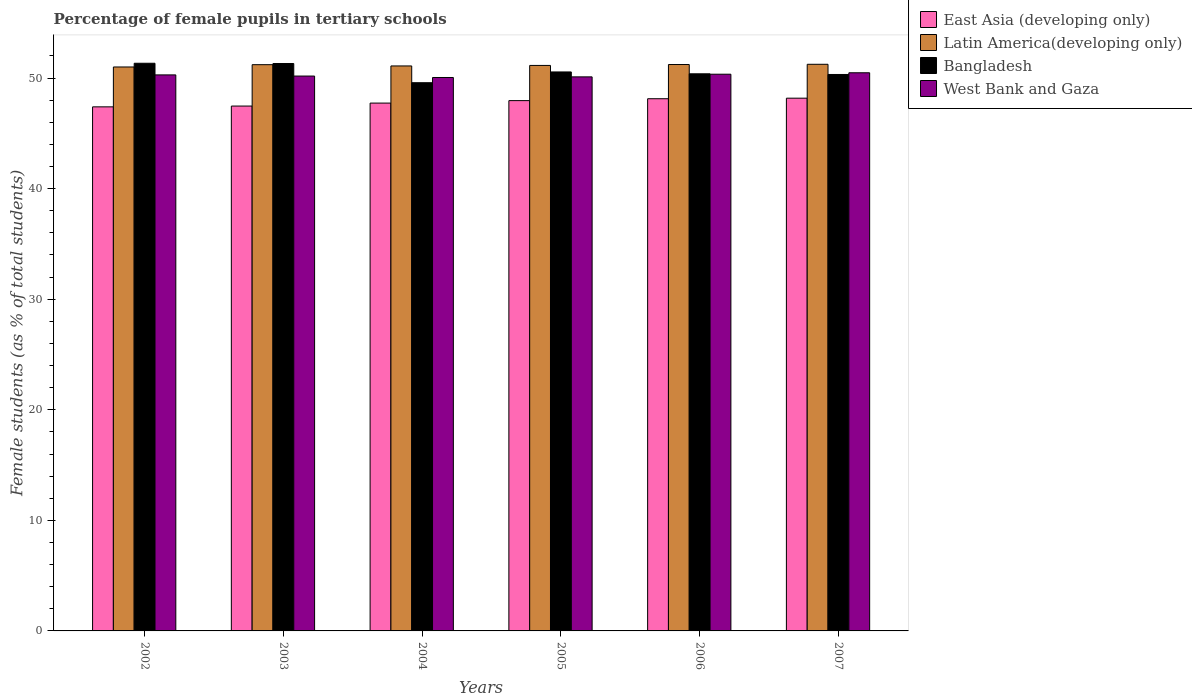How many groups of bars are there?
Offer a terse response. 6. Are the number of bars on each tick of the X-axis equal?
Provide a succinct answer. Yes. How many bars are there on the 3rd tick from the left?
Your answer should be very brief. 4. How many bars are there on the 4th tick from the right?
Keep it short and to the point. 4. What is the label of the 5th group of bars from the left?
Provide a succinct answer. 2006. What is the percentage of female pupils in tertiary schools in West Bank and Gaza in 2006?
Give a very brief answer. 50.35. Across all years, what is the maximum percentage of female pupils in tertiary schools in East Asia (developing only)?
Ensure brevity in your answer.  48.18. Across all years, what is the minimum percentage of female pupils in tertiary schools in East Asia (developing only)?
Provide a succinct answer. 47.4. In which year was the percentage of female pupils in tertiary schools in Latin America(developing only) maximum?
Ensure brevity in your answer.  2007. In which year was the percentage of female pupils in tertiary schools in East Asia (developing only) minimum?
Give a very brief answer. 2002. What is the total percentage of female pupils in tertiary schools in Bangladesh in the graph?
Offer a very short reply. 303.49. What is the difference between the percentage of female pupils in tertiary schools in Bangladesh in 2002 and that in 2007?
Your answer should be very brief. 1.01. What is the difference between the percentage of female pupils in tertiary schools in Bangladesh in 2003 and the percentage of female pupils in tertiary schools in Latin America(developing only) in 2005?
Make the answer very short. 0.17. What is the average percentage of female pupils in tertiary schools in East Asia (developing only) per year?
Offer a terse response. 47.81. In the year 2006, what is the difference between the percentage of female pupils in tertiary schools in Bangladesh and percentage of female pupils in tertiary schools in West Bank and Gaza?
Provide a short and direct response. 0.04. In how many years, is the percentage of female pupils in tertiary schools in Bangladesh greater than 12 %?
Offer a very short reply. 6. What is the ratio of the percentage of female pupils in tertiary schools in Latin America(developing only) in 2006 to that in 2007?
Ensure brevity in your answer.  1. Is the difference between the percentage of female pupils in tertiary schools in Bangladesh in 2003 and 2005 greater than the difference between the percentage of female pupils in tertiary schools in West Bank and Gaza in 2003 and 2005?
Provide a succinct answer. Yes. What is the difference between the highest and the second highest percentage of female pupils in tertiary schools in West Bank and Gaza?
Your response must be concise. 0.13. What is the difference between the highest and the lowest percentage of female pupils in tertiary schools in Bangladesh?
Your response must be concise. 1.76. In how many years, is the percentage of female pupils in tertiary schools in East Asia (developing only) greater than the average percentage of female pupils in tertiary schools in East Asia (developing only) taken over all years?
Keep it short and to the point. 3. Is the sum of the percentage of female pupils in tertiary schools in Latin America(developing only) in 2005 and 2007 greater than the maximum percentage of female pupils in tertiary schools in East Asia (developing only) across all years?
Offer a very short reply. Yes. Is it the case that in every year, the sum of the percentage of female pupils in tertiary schools in Bangladesh and percentage of female pupils in tertiary schools in East Asia (developing only) is greater than the sum of percentage of female pupils in tertiary schools in Latin America(developing only) and percentage of female pupils in tertiary schools in West Bank and Gaza?
Make the answer very short. No. What does the 1st bar from the left in 2006 represents?
Keep it short and to the point. East Asia (developing only). What does the 1st bar from the right in 2002 represents?
Offer a very short reply. West Bank and Gaza. How many years are there in the graph?
Your answer should be compact. 6. Are the values on the major ticks of Y-axis written in scientific E-notation?
Your answer should be compact. No. Does the graph contain any zero values?
Your response must be concise. No. What is the title of the graph?
Provide a short and direct response. Percentage of female pupils in tertiary schools. Does "Kyrgyz Republic" appear as one of the legend labels in the graph?
Your answer should be very brief. No. What is the label or title of the Y-axis?
Your answer should be compact. Female students (as % of total students). What is the Female students (as % of total students) in East Asia (developing only) in 2002?
Your response must be concise. 47.4. What is the Female students (as % of total students) in Latin America(developing only) in 2002?
Provide a succinct answer. 51. What is the Female students (as % of total students) of Bangladesh in 2002?
Ensure brevity in your answer.  51.34. What is the Female students (as % of total students) of West Bank and Gaza in 2002?
Offer a terse response. 50.29. What is the Female students (as % of total students) of East Asia (developing only) in 2003?
Your answer should be very brief. 47.47. What is the Female students (as % of total students) of Latin America(developing only) in 2003?
Provide a succinct answer. 51.21. What is the Female students (as % of total students) in Bangladesh in 2003?
Give a very brief answer. 51.31. What is the Female students (as % of total students) of West Bank and Gaza in 2003?
Your answer should be very brief. 50.18. What is the Female students (as % of total students) of East Asia (developing only) in 2004?
Provide a succinct answer. 47.74. What is the Female students (as % of total students) in Latin America(developing only) in 2004?
Offer a very short reply. 51.1. What is the Female students (as % of total students) of Bangladesh in 2004?
Your answer should be compact. 49.58. What is the Female students (as % of total students) in West Bank and Gaza in 2004?
Your response must be concise. 50.05. What is the Female students (as % of total students) in East Asia (developing only) in 2005?
Give a very brief answer. 47.96. What is the Female students (as % of total students) of Latin America(developing only) in 2005?
Offer a very short reply. 51.14. What is the Female students (as % of total students) in Bangladesh in 2005?
Ensure brevity in your answer.  50.55. What is the Female students (as % of total students) in West Bank and Gaza in 2005?
Your answer should be compact. 50.11. What is the Female students (as % of total students) in East Asia (developing only) in 2006?
Keep it short and to the point. 48.13. What is the Female students (as % of total students) of Latin America(developing only) in 2006?
Offer a terse response. 51.22. What is the Female students (as % of total students) in Bangladesh in 2006?
Keep it short and to the point. 50.38. What is the Female students (as % of total students) in West Bank and Gaza in 2006?
Provide a succinct answer. 50.35. What is the Female students (as % of total students) in East Asia (developing only) in 2007?
Your answer should be very brief. 48.18. What is the Female students (as % of total students) in Latin America(developing only) in 2007?
Ensure brevity in your answer.  51.24. What is the Female students (as % of total students) in Bangladesh in 2007?
Provide a short and direct response. 50.32. What is the Female students (as % of total students) in West Bank and Gaza in 2007?
Give a very brief answer. 50.48. Across all years, what is the maximum Female students (as % of total students) in East Asia (developing only)?
Your response must be concise. 48.18. Across all years, what is the maximum Female students (as % of total students) of Latin America(developing only)?
Provide a short and direct response. 51.24. Across all years, what is the maximum Female students (as % of total students) in Bangladesh?
Provide a succinct answer. 51.34. Across all years, what is the maximum Female students (as % of total students) of West Bank and Gaza?
Provide a short and direct response. 50.48. Across all years, what is the minimum Female students (as % of total students) in East Asia (developing only)?
Your answer should be very brief. 47.4. Across all years, what is the minimum Female students (as % of total students) of Latin America(developing only)?
Make the answer very short. 51. Across all years, what is the minimum Female students (as % of total students) of Bangladesh?
Keep it short and to the point. 49.58. Across all years, what is the minimum Female students (as % of total students) in West Bank and Gaza?
Give a very brief answer. 50.05. What is the total Female students (as % of total students) in East Asia (developing only) in the graph?
Ensure brevity in your answer.  286.87. What is the total Female students (as % of total students) of Latin America(developing only) in the graph?
Give a very brief answer. 306.92. What is the total Female students (as % of total students) in Bangladesh in the graph?
Offer a terse response. 303.49. What is the total Female students (as % of total students) in West Bank and Gaza in the graph?
Your answer should be very brief. 301.45. What is the difference between the Female students (as % of total students) of East Asia (developing only) in 2002 and that in 2003?
Provide a short and direct response. -0.07. What is the difference between the Female students (as % of total students) in Latin America(developing only) in 2002 and that in 2003?
Provide a short and direct response. -0.21. What is the difference between the Female students (as % of total students) in Bangladesh in 2002 and that in 2003?
Keep it short and to the point. 0.02. What is the difference between the Female students (as % of total students) of West Bank and Gaza in 2002 and that in 2003?
Your answer should be very brief. 0.1. What is the difference between the Female students (as % of total students) of East Asia (developing only) in 2002 and that in 2004?
Offer a terse response. -0.34. What is the difference between the Female students (as % of total students) in Latin America(developing only) in 2002 and that in 2004?
Offer a terse response. -0.09. What is the difference between the Female students (as % of total students) in Bangladesh in 2002 and that in 2004?
Your answer should be very brief. 1.76. What is the difference between the Female students (as % of total students) of West Bank and Gaza in 2002 and that in 2004?
Your answer should be very brief. 0.24. What is the difference between the Female students (as % of total students) in East Asia (developing only) in 2002 and that in 2005?
Offer a very short reply. -0.56. What is the difference between the Female students (as % of total students) in Latin America(developing only) in 2002 and that in 2005?
Offer a very short reply. -0.14. What is the difference between the Female students (as % of total students) of Bangladesh in 2002 and that in 2005?
Keep it short and to the point. 0.79. What is the difference between the Female students (as % of total students) in West Bank and Gaza in 2002 and that in 2005?
Your response must be concise. 0.18. What is the difference between the Female students (as % of total students) in East Asia (developing only) in 2002 and that in 2006?
Ensure brevity in your answer.  -0.74. What is the difference between the Female students (as % of total students) in Latin America(developing only) in 2002 and that in 2006?
Ensure brevity in your answer.  -0.22. What is the difference between the Female students (as % of total students) of Bangladesh in 2002 and that in 2006?
Offer a terse response. 0.95. What is the difference between the Female students (as % of total students) in West Bank and Gaza in 2002 and that in 2006?
Make the answer very short. -0.06. What is the difference between the Female students (as % of total students) of East Asia (developing only) in 2002 and that in 2007?
Give a very brief answer. -0.78. What is the difference between the Female students (as % of total students) of Latin America(developing only) in 2002 and that in 2007?
Provide a short and direct response. -0.24. What is the difference between the Female students (as % of total students) in West Bank and Gaza in 2002 and that in 2007?
Keep it short and to the point. -0.19. What is the difference between the Female students (as % of total students) of East Asia (developing only) in 2003 and that in 2004?
Keep it short and to the point. -0.27. What is the difference between the Female students (as % of total students) of Latin America(developing only) in 2003 and that in 2004?
Provide a succinct answer. 0.11. What is the difference between the Female students (as % of total students) of Bangladesh in 2003 and that in 2004?
Offer a very short reply. 1.74. What is the difference between the Female students (as % of total students) in West Bank and Gaza in 2003 and that in 2004?
Provide a succinct answer. 0.13. What is the difference between the Female students (as % of total students) in East Asia (developing only) in 2003 and that in 2005?
Keep it short and to the point. -0.49. What is the difference between the Female students (as % of total students) of Latin America(developing only) in 2003 and that in 2005?
Provide a succinct answer. 0.07. What is the difference between the Female students (as % of total students) of Bangladesh in 2003 and that in 2005?
Your answer should be very brief. 0.76. What is the difference between the Female students (as % of total students) of West Bank and Gaza in 2003 and that in 2005?
Offer a terse response. 0.07. What is the difference between the Female students (as % of total students) of East Asia (developing only) in 2003 and that in 2006?
Make the answer very short. -0.66. What is the difference between the Female students (as % of total students) of Latin America(developing only) in 2003 and that in 2006?
Ensure brevity in your answer.  -0.01. What is the difference between the Female students (as % of total students) of Bangladesh in 2003 and that in 2006?
Your response must be concise. 0.93. What is the difference between the Female students (as % of total students) in West Bank and Gaza in 2003 and that in 2006?
Make the answer very short. -0.17. What is the difference between the Female students (as % of total students) of East Asia (developing only) in 2003 and that in 2007?
Your answer should be very brief. -0.71. What is the difference between the Female students (as % of total students) of Latin America(developing only) in 2003 and that in 2007?
Your answer should be compact. -0.04. What is the difference between the Female students (as % of total students) of West Bank and Gaza in 2003 and that in 2007?
Provide a short and direct response. -0.3. What is the difference between the Female students (as % of total students) in East Asia (developing only) in 2004 and that in 2005?
Offer a very short reply. -0.22. What is the difference between the Female students (as % of total students) in Latin America(developing only) in 2004 and that in 2005?
Offer a very short reply. -0.05. What is the difference between the Female students (as % of total students) in Bangladesh in 2004 and that in 2005?
Offer a very short reply. -0.97. What is the difference between the Female students (as % of total students) in West Bank and Gaza in 2004 and that in 2005?
Give a very brief answer. -0.06. What is the difference between the Female students (as % of total students) in East Asia (developing only) in 2004 and that in 2006?
Your answer should be very brief. -0.39. What is the difference between the Female students (as % of total students) of Latin America(developing only) in 2004 and that in 2006?
Keep it short and to the point. -0.13. What is the difference between the Female students (as % of total students) in Bangladesh in 2004 and that in 2006?
Give a very brief answer. -0.81. What is the difference between the Female students (as % of total students) in West Bank and Gaza in 2004 and that in 2006?
Give a very brief answer. -0.3. What is the difference between the Female students (as % of total students) in East Asia (developing only) in 2004 and that in 2007?
Your answer should be very brief. -0.44. What is the difference between the Female students (as % of total students) of Latin America(developing only) in 2004 and that in 2007?
Your answer should be compact. -0.15. What is the difference between the Female students (as % of total students) of Bangladesh in 2004 and that in 2007?
Keep it short and to the point. -0.75. What is the difference between the Female students (as % of total students) in West Bank and Gaza in 2004 and that in 2007?
Your answer should be compact. -0.43. What is the difference between the Female students (as % of total students) of East Asia (developing only) in 2005 and that in 2006?
Ensure brevity in your answer.  -0.17. What is the difference between the Female students (as % of total students) of Latin America(developing only) in 2005 and that in 2006?
Make the answer very short. -0.08. What is the difference between the Female students (as % of total students) of Bangladesh in 2005 and that in 2006?
Offer a terse response. 0.17. What is the difference between the Female students (as % of total students) of West Bank and Gaza in 2005 and that in 2006?
Provide a succinct answer. -0.24. What is the difference between the Female students (as % of total students) in East Asia (developing only) in 2005 and that in 2007?
Your answer should be compact. -0.22. What is the difference between the Female students (as % of total students) in Latin America(developing only) in 2005 and that in 2007?
Your response must be concise. -0.1. What is the difference between the Female students (as % of total students) of Bangladesh in 2005 and that in 2007?
Your response must be concise. 0.23. What is the difference between the Female students (as % of total students) of West Bank and Gaza in 2005 and that in 2007?
Your response must be concise. -0.37. What is the difference between the Female students (as % of total students) in East Asia (developing only) in 2006 and that in 2007?
Your answer should be compact. -0.05. What is the difference between the Female students (as % of total students) in Latin America(developing only) in 2006 and that in 2007?
Provide a succinct answer. -0.02. What is the difference between the Female students (as % of total students) of Bangladesh in 2006 and that in 2007?
Ensure brevity in your answer.  0.06. What is the difference between the Female students (as % of total students) in West Bank and Gaza in 2006 and that in 2007?
Keep it short and to the point. -0.13. What is the difference between the Female students (as % of total students) in East Asia (developing only) in 2002 and the Female students (as % of total students) in Latin America(developing only) in 2003?
Keep it short and to the point. -3.81. What is the difference between the Female students (as % of total students) of East Asia (developing only) in 2002 and the Female students (as % of total students) of Bangladesh in 2003?
Your response must be concise. -3.92. What is the difference between the Female students (as % of total students) in East Asia (developing only) in 2002 and the Female students (as % of total students) in West Bank and Gaza in 2003?
Your answer should be very brief. -2.79. What is the difference between the Female students (as % of total students) in Latin America(developing only) in 2002 and the Female students (as % of total students) in Bangladesh in 2003?
Make the answer very short. -0.31. What is the difference between the Female students (as % of total students) in Latin America(developing only) in 2002 and the Female students (as % of total students) in West Bank and Gaza in 2003?
Your answer should be compact. 0.82. What is the difference between the Female students (as % of total students) of Bangladesh in 2002 and the Female students (as % of total students) of West Bank and Gaza in 2003?
Give a very brief answer. 1.16. What is the difference between the Female students (as % of total students) in East Asia (developing only) in 2002 and the Female students (as % of total students) in Latin America(developing only) in 2004?
Provide a short and direct response. -3.7. What is the difference between the Female students (as % of total students) in East Asia (developing only) in 2002 and the Female students (as % of total students) in Bangladesh in 2004?
Provide a short and direct response. -2.18. What is the difference between the Female students (as % of total students) of East Asia (developing only) in 2002 and the Female students (as % of total students) of West Bank and Gaza in 2004?
Provide a short and direct response. -2.66. What is the difference between the Female students (as % of total students) of Latin America(developing only) in 2002 and the Female students (as % of total students) of Bangladesh in 2004?
Your answer should be very brief. 1.42. What is the difference between the Female students (as % of total students) in Latin America(developing only) in 2002 and the Female students (as % of total students) in West Bank and Gaza in 2004?
Provide a short and direct response. 0.95. What is the difference between the Female students (as % of total students) in Bangladesh in 2002 and the Female students (as % of total students) in West Bank and Gaza in 2004?
Make the answer very short. 1.29. What is the difference between the Female students (as % of total students) in East Asia (developing only) in 2002 and the Female students (as % of total students) in Latin America(developing only) in 2005?
Your answer should be very brief. -3.75. What is the difference between the Female students (as % of total students) of East Asia (developing only) in 2002 and the Female students (as % of total students) of Bangladesh in 2005?
Make the answer very short. -3.16. What is the difference between the Female students (as % of total students) of East Asia (developing only) in 2002 and the Female students (as % of total students) of West Bank and Gaza in 2005?
Your answer should be very brief. -2.71. What is the difference between the Female students (as % of total students) in Latin America(developing only) in 2002 and the Female students (as % of total students) in Bangladesh in 2005?
Your answer should be very brief. 0.45. What is the difference between the Female students (as % of total students) of Latin America(developing only) in 2002 and the Female students (as % of total students) of West Bank and Gaza in 2005?
Provide a short and direct response. 0.9. What is the difference between the Female students (as % of total students) of Bangladesh in 2002 and the Female students (as % of total students) of West Bank and Gaza in 2005?
Provide a short and direct response. 1.23. What is the difference between the Female students (as % of total students) of East Asia (developing only) in 2002 and the Female students (as % of total students) of Latin America(developing only) in 2006?
Make the answer very short. -3.83. What is the difference between the Female students (as % of total students) of East Asia (developing only) in 2002 and the Female students (as % of total students) of Bangladesh in 2006?
Offer a terse response. -2.99. What is the difference between the Female students (as % of total students) in East Asia (developing only) in 2002 and the Female students (as % of total students) in West Bank and Gaza in 2006?
Make the answer very short. -2.95. What is the difference between the Female students (as % of total students) of Latin America(developing only) in 2002 and the Female students (as % of total students) of Bangladesh in 2006?
Your answer should be compact. 0.62. What is the difference between the Female students (as % of total students) in Latin America(developing only) in 2002 and the Female students (as % of total students) in West Bank and Gaza in 2006?
Offer a terse response. 0.65. What is the difference between the Female students (as % of total students) in Bangladesh in 2002 and the Female students (as % of total students) in West Bank and Gaza in 2006?
Provide a succinct answer. 0.99. What is the difference between the Female students (as % of total students) of East Asia (developing only) in 2002 and the Female students (as % of total students) of Latin America(developing only) in 2007?
Give a very brief answer. -3.85. What is the difference between the Female students (as % of total students) in East Asia (developing only) in 2002 and the Female students (as % of total students) in Bangladesh in 2007?
Your response must be concise. -2.93. What is the difference between the Female students (as % of total students) of East Asia (developing only) in 2002 and the Female students (as % of total students) of West Bank and Gaza in 2007?
Provide a short and direct response. -3.08. What is the difference between the Female students (as % of total students) in Latin America(developing only) in 2002 and the Female students (as % of total students) in Bangladesh in 2007?
Your answer should be very brief. 0.68. What is the difference between the Female students (as % of total students) in Latin America(developing only) in 2002 and the Female students (as % of total students) in West Bank and Gaza in 2007?
Your answer should be compact. 0.53. What is the difference between the Female students (as % of total students) in Bangladesh in 2002 and the Female students (as % of total students) in West Bank and Gaza in 2007?
Offer a terse response. 0.86. What is the difference between the Female students (as % of total students) of East Asia (developing only) in 2003 and the Female students (as % of total students) of Latin America(developing only) in 2004?
Give a very brief answer. -3.63. What is the difference between the Female students (as % of total students) of East Asia (developing only) in 2003 and the Female students (as % of total students) of Bangladesh in 2004?
Provide a succinct answer. -2.11. What is the difference between the Female students (as % of total students) in East Asia (developing only) in 2003 and the Female students (as % of total students) in West Bank and Gaza in 2004?
Your answer should be very brief. -2.58. What is the difference between the Female students (as % of total students) of Latin America(developing only) in 2003 and the Female students (as % of total students) of Bangladesh in 2004?
Provide a succinct answer. 1.63. What is the difference between the Female students (as % of total students) in Latin America(developing only) in 2003 and the Female students (as % of total students) in West Bank and Gaza in 2004?
Your answer should be compact. 1.16. What is the difference between the Female students (as % of total students) in Bangladesh in 2003 and the Female students (as % of total students) in West Bank and Gaza in 2004?
Offer a terse response. 1.26. What is the difference between the Female students (as % of total students) of East Asia (developing only) in 2003 and the Female students (as % of total students) of Latin America(developing only) in 2005?
Your answer should be compact. -3.68. What is the difference between the Female students (as % of total students) in East Asia (developing only) in 2003 and the Female students (as % of total students) in Bangladesh in 2005?
Offer a terse response. -3.09. What is the difference between the Female students (as % of total students) in East Asia (developing only) in 2003 and the Female students (as % of total students) in West Bank and Gaza in 2005?
Provide a short and direct response. -2.64. What is the difference between the Female students (as % of total students) of Latin America(developing only) in 2003 and the Female students (as % of total students) of Bangladesh in 2005?
Give a very brief answer. 0.66. What is the difference between the Female students (as % of total students) of Latin America(developing only) in 2003 and the Female students (as % of total students) of West Bank and Gaza in 2005?
Provide a succinct answer. 1.1. What is the difference between the Female students (as % of total students) of Bangladesh in 2003 and the Female students (as % of total students) of West Bank and Gaza in 2005?
Your response must be concise. 1.21. What is the difference between the Female students (as % of total students) of East Asia (developing only) in 2003 and the Female students (as % of total students) of Latin America(developing only) in 2006?
Offer a very short reply. -3.76. What is the difference between the Female students (as % of total students) of East Asia (developing only) in 2003 and the Female students (as % of total students) of Bangladesh in 2006?
Offer a terse response. -2.92. What is the difference between the Female students (as % of total students) in East Asia (developing only) in 2003 and the Female students (as % of total students) in West Bank and Gaza in 2006?
Your answer should be very brief. -2.88. What is the difference between the Female students (as % of total students) in Latin America(developing only) in 2003 and the Female students (as % of total students) in Bangladesh in 2006?
Provide a short and direct response. 0.82. What is the difference between the Female students (as % of total students) of Latin America(developing only) in 2003 and the Female students (as % of total students) of West Bank and Gaza in 2006?
Provide a short and direct response. 0.86. What is the difference between the Female students (as % of total students) of Bangladesh in 2003 and the Female students (as % of total students) of West Bank and Gaza in 2006?
Offer a terse response. 0.97. What is the difference between the Female students (as % of total students) of East Asia (developing only) in 2003 and the Female students (as % of total students) of Latin America(developing only) in 2007?
Your response must be concise. -3.78. What is the difference between the Female students (as % of total students) of East Asia (developing only) in 2003 and the Female students (as % of total students) of Bangladesh in 2007?
Offer a very short reply. -2.86. What is the difference between the Female students (as % of total students) in East Asia (developing only) in 2003 and the Female students (as % of total students) in West Bank and Gaza in 2007?
Offer a very short reply. -3.01. What is the difference between the Female students (as % of total students) in Latin America(developing only) in 2003 and the Female students (as % of total students) in Bangladesh in 2007?
Offer a very short reply. 0.88. What is the difference between the Female students (as % of total students) in Latin America(developing only) in 2003 and the Female students (as % of total students) in West Bank and Gaza in 2007?
Your answer should be very brief. 0.73. What is the difference between the Female students (as % of total students) of Bangladesh in 2003 and the Female students (as % of total students) of West Bank and Gaza in 2007?
Provide a short and direct response. 0.84. What is the difference between the Female students (as % of total students) of East Asia (developing only) in 2004 and the Female students (as % of total students) of Latin America(developing only) in 2005?
Offer a terse response. -3.41. What is the difference between the Female students (as % of total students) of East Asia (developing only) in 2004 and the Female students (as % of total students) of Bangladesh in 2005?
Provide a short and direct response. -2.82. What is the difference between the Female students (as % of total students) in East Asia (developing only) in 2004 and the Female students (as % of total students) in West Bank and Gaza in 2005?
Your answer should be very brief. -2.37. What is the difference between the Female students (as % of total students) of Latin America(developing only) in 2004 and the Female students (as % of total students) of Bangladesh in 2005?
Your response must be concise. 0.54. What is the difference between the Female students (as % of total students) in Latin America(developing only) in 2004 and the Female students (as % of total students) in West Bank and Gaza in 2005?
Provide a succinct answer. 0.99. What is the difference between the Female students (as % of total students) in Bangladesh in 2004 and the Female students (as % of total students) in West Bank and Gaza in 2005?
Your answer should be very brief. -0.53. What is the difference between the Female students (as % of total students) of East Asia (developing only) in 2004 and the Female students (as % of total students) of Latin America(developing only) in 2006?
Your response must be concise. -3.49. What is the difference between the Female students (as % of total students) of East Asia (developing only) in 2004 and the Female students (as % of total students) of Bangladesh in 2006?
Give a very brief answer. -2.65. What is the difference between the Female students (as % of total students) in East Asia (developing only) in 2004 and the Female students (as % of total students) in West Bank and Gaza in 2006?
Keep it short and to the point. -2.61. What is the difference between the Female students (as % of total students) of Latin America(developing only) in 2004 and the Female students (as % of total students) of Bangladesh in 2006?
Your answer should be very brief. 0.71. What is the difference between the Female students (as % of total students) of Latin America(developing only) in 2004 and the Female students (as % of total students) of West Bank and Gaza in 2006?
Give a very brief answer. 0.75. What is the difference between the Female students (as % of total students) in Bangladesh in 2004 and the Female students (as % of total students) in West Bank and Gaza in 2006?
Make the answer very short. -0.77. What is the difference between the Female students (as % of total students) of East Asia (developing only) in 2004 and the Female students (as % of total students) of Latin America(developing only) in 2007?
Give a very brief answer. -3.51. What is the difference between the Female students (as % of total students) in East Asia (developing only) in 2004 and the Female students (as % of total students) in Bangladesh in 2007?
Provide a short and direct response. -2.59. What is the difference between the Female students (as % of total students) of East Asia (developing only) in 2004 and the Female students (as % of total students) of West Bank and Gaza in 2007?
Make the answer very short. -2.74. What is the difference between the Female students (as % of total students) in Latin America(developing only) in 2004 and the Female students (as % of total students) in Bangladesh in 2007?
Your response must be concise. 0.77. What is the difference between the Female students (as % of total students) of Latin America(developing only) in 2004 and the Female students (as % of total students) of West Bank and Gaza in 2007?
Provide a short and direct response. 0.62. What is the difference between the Female students (as % of total students) in Bangladesh in 2004 and the Female students (as % of total students) in West Bank and Gaza in 2007?
Your response must be concise. -0.9. What is the difference between the Female students (as % of total students) in East Asia (developing only) in 2005 and the Female students (as % of total students) in Latin America(developing only) in 2006?
Offer a terse response. -3.26. What is the difference between the Female students (as % of total students) of East Asia (developing only) in 2005 and the Female students (as % of total students) of Bangladesh in 2006?
Offer a very short reply. -2.42. What is the difference between the Female students (as % of total students) in East Asia (developing only) in 2005 and the Female students (as % of total students) in West Bank and Gaza in 2006?
Your response must be concise. -2.39. What is the difference between the Female students (as % of total students) of Latin America(developing only) in 2005 and the Female students (as % of total students) of Bangladesh in 2006?
Your answer should be very brief. 0.76. What is the difference between the Female students (as % of total students) in Latin America(developing only) in 2005 and the Female students (as % of total students) in West Bank and Gaza in 2006?
Make the answer very short. 0.79. What is the difference between the Female students (as % of total students) of Bangladesh in 2005 and the Female students (as % of total students) of West Bank and Gaza in 2006?
Provide a short and direct response. 0.2. What is the difference between the Female students (as % of total students) of East Asia (developing only) in 2005 and the Female students (as % of total students) of Latin America(developing only) in 2007?
Ensure brevity in your answer.  -3.28. What is the difference between the Female students (as % of total students) of East Asia (developing only) in 2005 and the Female students (as % of total students) of Bangladesh in 2007?
Offer a terse response. -2.36. What is the difference between the Female students (as % of total students) of East Asia (developing only) in 2005 and the Female students (as % of total students) of West Bank and Gaza in 2007?
Ensure brevity in your answer.  -2.52. What is the difference between the Female students (as % of total students) in Latin America(developing only) in 2005 and the Female students (as % of total students) in Bangladesh in 2007?
Offer a terse response. 0.82. What is the difference between the Female students (as % of total students) in Latin America(developing only) in 2005 and the Female students (as % of total students) in West Bank and Gaza in 2007?
Keep it short and to the point. 0.67. What is the difference between the Female students (as % of total students) in Bangladesh in 2005 and the Female students (as % of total students) in West Bank and Gaza in 2007?
Make the answer very short. 0.08. What is the difference between the Female students (as % of total students) in East Asia (developing only) in 2006 and the Female students (as % of total students) in Latin America(developing only) in 2007?
Your answer should be very brief. -3.11. What is the difference between the Female students (as % of total students) in East Asia (developing only) in 2006 and the Female students (as % of total students) in Bangladesh in 2007?
Provide a succinct answer. -2.19. What is the difference between the Female students (as % of total students) in East Asia (developing only) in 2006 and the Female students (as % of total students) in West Bank and Gaza in 2007?
Keep it short and to the point. -2.35. What is the difference between the Female students (as % of total students) in Latin America(developing only) in 2006 and the Female students (as % of total students) in Bangladesh in 2007?
Provide a succinct answer. 0.9. What is the difference between the Female students (as % of total students) of Latin America(developing only) in 2006 and the Female students (as % of total students) of West Bank and Gaza in 2007?
Offer a very short reply. 0.75. What is the difference between the Female students (as % of total students) in Bangladesh in 2006 and the Female students (as % of total students) in West Bank and Gaza in 2007?
Ensure brevity in your answer.  -0.09. What is the average Female students (as % of total students) of East Asia (developing only) per year?
Provide a short and direct response. 47.81. What is the average Female students (as % of total students) in Latin America(developing only) per year?
Make the answer very short. 51.15. What is the average Female students (as % of total students) of Bangladesh per year?
Your answer should be very brief. 50.58. What is the average Female students (as % of total students) in West Bank and Gaza per year?
Provide a short and direct response. 50.24. In the year 2002, what is the difference between the Female students (as % of total students) in East Asia (developing only) and Female students (as % of total students) in Latin America(developing only)?
Make the answer very short. -3.61. In the year 2002, what is the difference between the Female students (as % of total students) in East Asia (developing only) and Female students (as % of total students) in Bangladesh?
Provide a short and direct response. -3.94. In the year 2002, what is the difference between the Female students (as % of total students) of East Asia (developing only) and Female students (as % of total students) of West Bank and Gaza?
Your answer should be compact. -2.89. In the year 2002, what is the difference between the Female students (as % of total students) of Latin America(developing only) and Female students (as % of total students) of Bangladesh?
Offer a terse response. -0.34. In the year 2002, what is the difference between the Female students (as % of total students) of Latin America(developing only) and Female students (as % of total students) of West Bank and Gaza?
Your answer should be very brief. 0.72. In the year 2002, what is the difference between the Female students (as % of total students) of Bangladesh and Female students (as % of total students) of West Bank and Gaza?
Your response must be concise. 1.05. In the year 2003, what is the difference between the Female students (as % of total students) of East Asia (developing only) and Female students (as % of total students) of Latin America(developing only)?
Your answer should be very brief. -3.74. In the year 2003, what is the difference between the Female students (as % of total students) in East Asia (developing only) and Female students (as % of total students) in Bangladesh?
Your answer should be compact. -3.85. In the year 2003, what is the difference between the Female students (as % of total students) of East Asia (developing only) and Female students (as % of total students) of West Bank and Gaza?
Make the answer very short. -2.71. In the year 2003, what is the difference between the Female students (as % of total students) of Latin America(developing only) and Female students (as % of total students) of Bangladesh?
Give a very brief answer. -0.11. In the year 2003, what is the difference between the Female students (as % of total students) of Latin America(developing only) and Female students (as % of total students) of West Bank and Gaza?
Provide a short and direct response. 1.03. In the year 2003, what is the difference between the Female students (as % of total students) of Bangladesh and Female students (as % of total students) of West Bank and Gaza?
Your answer should be very brief. 1.13. In the year 2004, what is the difference between the Female students (as % of total students) in East Asia (developing only) and Female students (as % of total students) in Latin America(developing only)?
Offer a very short reply. -3.36. In the year 2004, what is the difference between the Female students (as % of total students) in East Asia (developing only) and Female students (as % of total students) in Bangladesh?
Give a very brief answer. -1.84. In the year 2004, what is the difference between the Female students (as % of total students) of East Asia (developing only) and Female students (as % of total students) of West Bank and Gaza?
Keep it short and to the point. -2.31. In the year 2004, what is the difference between the Female students (as % of total students) in Latin America(developing only) and Female students (as % of total students) in Bangladesh?
Ensure brevity in your answer.  1.52. In the year 2004, what is the difference between the Female students (as % of total students) of Latin America(developing only) and Female students (as % of total students) of West Bank and Gaza?
Offer a terse response. 1.04. In the year 2004, what is the difference between the Female students (as % of total students) in Bangladesh and Female students (as % of total students) in West Bank and Gaza?
Make the answer very short. -0.47. In the year 2005, what is the difference between the Female students (as % of total students) in East Asia (developing only) and Female students (as % of total students) in Latin America(developing only)?
Give a very brief answer. -3.18. In the year 2005, what is the difference between the Female students (as % of total students) of East Asia (developing only) and Female students (as % of total students) of Bangladesh?
Give a very brief answer. -2.59. In the year 2005, what is the difference between the Female students (as % of total students) in East Asia (developing only) and Female students (as % of total students) in West Bank and Gaza?
Give a very brief answer. -2.15. In the year 2005, what is the difference between the Female students (as % of total students) of Latin America(developing only) and Female students (as % of total students) of Bangladesh?
Offer a very short reply. 0.59. In the year 2005, what is the difference between the Female students (as % of total students) of Latin America(developing only) and Female students (as % of total students) of West Bank and Gaza?
Offer a terse response. 1.04. In the year 2005, what is the difference between the Female students (as % of total students) of Bangladesh and Female students (as % of total students) of West Bank and Gaza?
Ensure brevity in your answer.  0.45. In the year 2006, what is the difference between the Female students (as % of total students) of East Asia (developing only) and Female students (as % of total students) of Latin America(developing only)?
Provide a succinct answer. -3.09. In the year 2006, what is the difference between the Female students (as % of total students) of East Asia (developing only) and Female students (as % of total students) of Bangladesh?
Give a very brief answer. -2.25. In the year 2006, what is the difference between the Female students (as % of total students) in East Asia (developing only) and Female students (as % of total students) in West Bank and Gaza?
Offer a terse response. -2.22. In the year 2006, what is the difference between the Female students (as % of total students) in Latin America(developing only) and Female students (as % of total students) in Bangladesh?
Offer a terse response. 0.84. In the year 2006, what is the difference between the Female students (as % of total students) of Latin America(developing only) and Female students (as % of total students) of West Bank and Gaza?
Offer a terse response. 0.88. In the year 2006, what is the difference between the Female students (as % of total students) of Bangladesh and Female students (as % of total students) of West Bank and Gaza?
Offer a terse response. 0.04. In the year 2007, what is the difference between the Female students (as % of total students) in East Asia (developing only) and Female students (as % of total students) in Latin America(developing only)?
Offer a terse response. -3.06. In the year 2007, what is the difference between the Female students (as % of total students) in East Asia (developing only) and Female students (as % of total students) in Bangladesh?
Offer a very short reply. -2.14. In the year 2007, what is the difference between the Female students (as % of total students) of East Asia (developing only) and Female students (as % of total students) of West Bank and Gaza?
Give a very brief answer. -2.3. In the year 2007, what is the difference between the Female students (as % of total students) in Latin America(developing only) and Female students (as % of total students) in Bangladesh?
Offer a very short reply. 0.92. In the year 2007, what is the difference between the Female students (as % of total students) of Latin America(developing only) and Female students (as % of total students) of West Bank and Gaza?
Your answer should be very brief. 0.77. In the year 2007, what is the difference between the Female students (as % of total students) in Bangladesh and Female students (as % of total students) in West Bank and Gaza?
Your answer should be very brief. -0.15. What is the ratio of the Female students (as % of total students) of Latin America(developing only) in 2002 to that in 2003?
Make the answer very short. 1. What is the ratio of the Female students (as % of total students) of West Bank and Gaza in 2002 to that in 2003?
Keep it short and to the point. 1. What is the ratio of the Female students (as % of total students) in Bangladesh in 2002 to that in 2004?
Your answer should be very brief. 1.04. What is the ratio of the Female students (as % of total students) of East Asia (developing only) in 2002 to that in 2005?
Keep it short and to the point. 0.99. What is the ratio of the Female students (as % of total students) in Latin America(developing only) in 2002 to that in 2005?
Provide a succinct answer. 1. What is the ratio of the Female students (as % of total students) of Bangladesh in 2002 to that in 2005?
Make the answer very short. 1.02. What is the ratio of the Female students (as % of total students) in East Asia (developing only) in 2002 to that in 2006?
Provide a succinct answer. 0.98. What is the ratio of the Female students (as % of total students) in Latin America(developing only) in 2002 to that in 2006?
Your answer should be very brief. 1. What is the ratio of the Female students (as % of total students) of Bangladesh in 2002 to that in 2006?
Your answer should be very brief. 1.02. What is the ratio of the Female students (as % of total students) of West Bank and Gaza in 2002 to that in 2006?
Your response must be concise. 1. What is the ratio of the Female students (as % of total students) in East Asia (developing only) in 2002 to that in 2007?
Give a very brief answer. 0.98. What is the ratio of the Female students (as % of total students) in Bangladesh in 2002 to that in 2007?
Ensure brevity in your answer.  1.02. What is the ratio of the Female students (as % of total students) in East Asia (developing only) in 2003 to that in 2004?
Offer a terse response. 0.99. What is the ratio of the Female students (as % of total students) in Latin America(developing only) in 2003 to that in 2004?
Offer a very short reply. 1. What is the ratio of the Female students (as % of total students) in Bangladesh in 2003 to that in 2004?
Make the answer very short. 1.03. What is the ratio of the Female students (as % of total students) of West Bank and Gaza in 2003 to that in 2004?
Your answer should be very brief. 1. What is the ratio of the Female students (as % of total students) in Latin America(developing only) in 2003 to that in 2005?
Provide a succinct answer. 1. What is the ratio of the Female students (as % of total students) in Bangladesh in 2003 to that in 2005?
Offer a very short reply. 1.02. What is the ratio of the Female students (as % of total students) of East Asia (developing only) in 2003 to that in 2006?
Ensure brevity in your answer.  0.99. What is the ratio of the Female students (as % of total students) in Latin America(developing only) in 2003 to that in 2006?
Your answer should be very brief. 1. What is the ratio of the Female students (as % of total students) in Bangladesh in 2003 to that in 2006?
Give a very brief answer. 1.02. What is the ratio of the Female students (as % of total students) of East Asia (developing only) in 2003 to that in 2007?
Your response must be concise. 0.99. What is the ratio of the Female students (as % of total students) in Latin America(developing only) in 2003 to that in 2007?
Your response must be concise. 1. What is the ratio of the Female students (as % of total students) of Bangladesh in 2003 to that in 2007?
Offer a terse response. 1.02. What is the ratio of the Female students (as % of total students) of East Asia (developing only) in 2004 to that in 2005?
Offer a terse response. 1. What is the ratio of the Female students (as % of total students) of Bangladesh in 2004 to that in 2005?
Offer a very short reply. 0.98. What is the ratio of the Female students (as % of total students) in West Bank and Gaza in 2004 to that in 2006?
Offer a terse response. 0.99. What is the ratio of the Female students (as % of total students) in East Asia (developing only) in 2004 to that in 2007?
Make the answer very short. 0.99. What is the ratio of the Female students (as % of total students) in Bangladesh in 2004 to that in 2007?
Offer a terse response. 0.99. What is the ratio of the Female students (as % of total students) of Latin America(developing only) in 2005 to that in 2006?
Your answer should be very brief. 1. What is the ratio of the Female students (as % of total students) in Bangladesh in 2005 to that in 2006?
Keep it short and to the point. 1. What is the ratio of the Female students (as % of total students) of West Bank and Gaza in 2005 to that in 2007?
Give a very brief answer. 0.99. What is the ratio of the Female students (as % of total students) in East Asia (developing only) in 2006 to that in 2007?
Provide a short and direct response. 1. What is the ratio of the Female students (as % of total students) in Bangladesh in 2006 to that in 2007?
Provide a succinct answer. 1. What is the ratio of the Female students (as % of total students) in West Bank and Gaza in 2006 to that in 2007?
Your answer should be compact. 1. What is the difference between the highest and the second highest Female students (as % of total students) of East Asia (developing only)?
Your response must be concise. 0.05. What is the difference between the highest and the second highest Female students (as % of total students) of Latin America(developing only)?
Your answer should be very brief. 0.02. What is the difference between the highest and the second highest Female students (as % of total students) of Bangladesh?
Offer a terse response. 0.02. What is the difference between the highest and the second highest Female students (as % of total students) in West Bank and Gaza?
Ensure brevity in your answer.  0.13. What is the difference between the highest and the lowest Female students (as % of total students) of East Asia (developing only)?
Offer a terse response. 0.78. What is the difference between the highest and the lowest Female students (as % of total students) in Latin America(developing only)?
Your answer should be compact. 0.24. What is the difference between the highest and the lowest Female students (as % of total students) of Bangladesh?
Your answer should be very brief. 1.76. What is the difference between the highest and the lowest Female students (as % of total students) of West Bank and Gaza?
Your response must be concise. 0.43. 